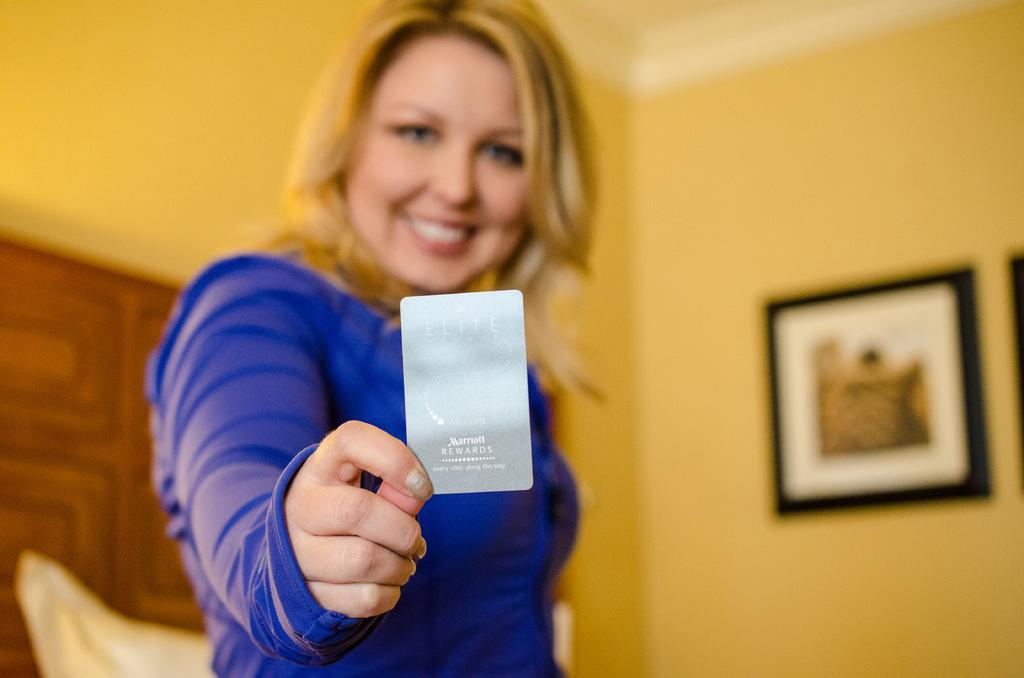What is the person in the image holding? There is a person holding an object in the image. What can be seen on the wall in the image? There is a wall with frames in the image. Can you describe the object located in the bottom left side of the image? There is an object in the bottom left side of the image. What type of drink is being served in the image? There is no drink present in the image. What boundary is depicted in the image? The image does not show any boundaries. 